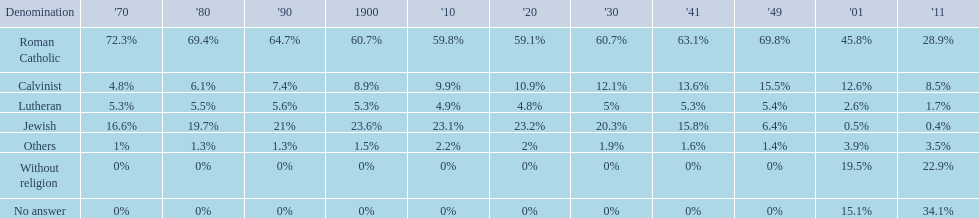What is the largest religious denomination in budapest? Roman Catholic. 